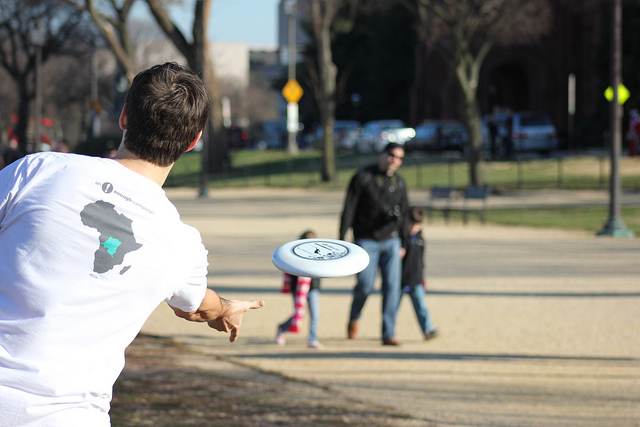What activity is shown in the image? The image captures a leisurely moment, with a person in the foreground throwing a frisbee towards another individual who's standing at a distance, ready to catch it. 